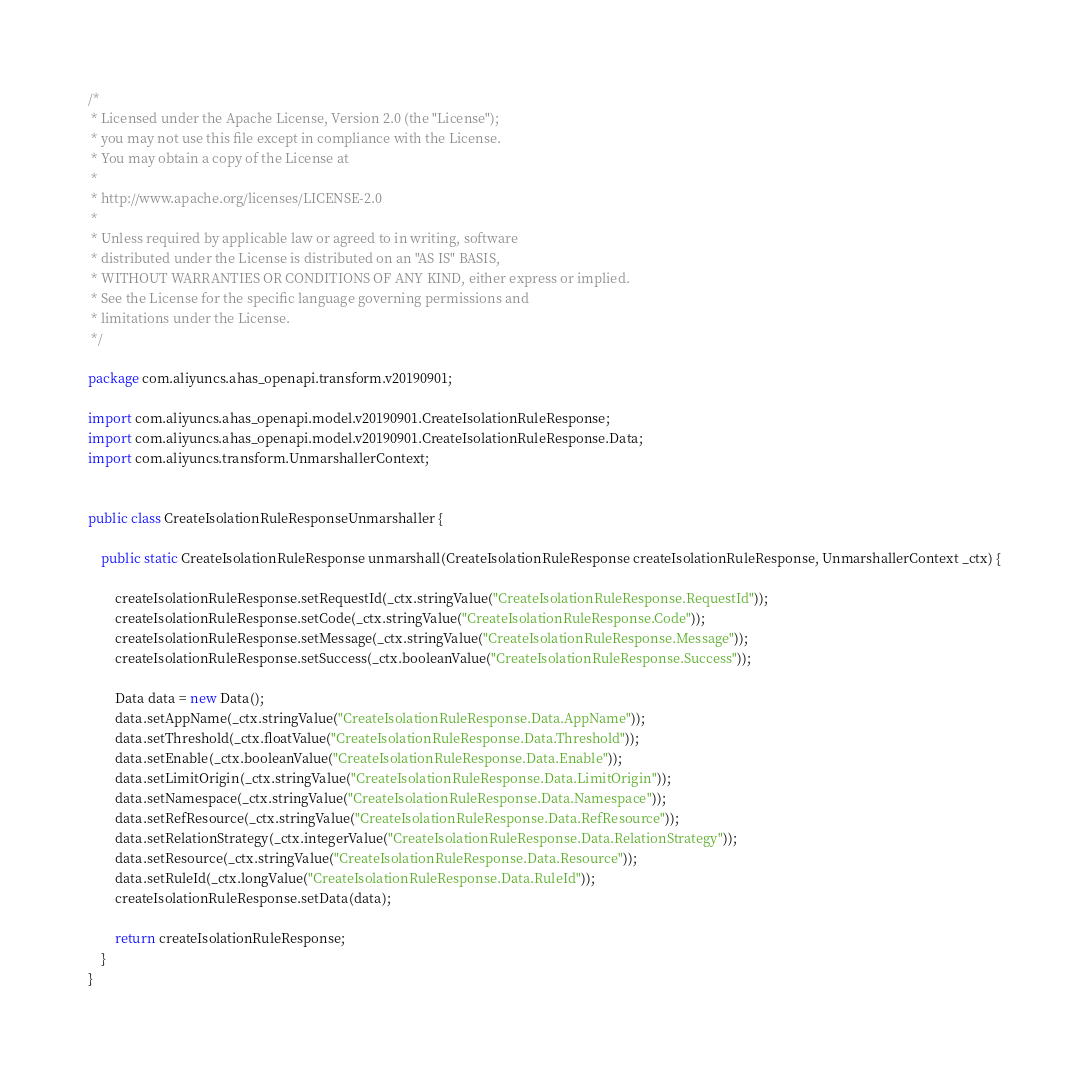Convert code to text. <code><loc_0><loc_0><loc_500><loc_500><_Java_>/*
 * Licensed under the Apache License, Version 2.0 (the "License");
 * you may not use this file except in compliance with the License.
 * You may obtain a copy of the License at
 *
 * http://www.apache.org/licenses/LICENSE-2.0
 *
 * Unless required by applicable law or agreed to in writing, software
 * distributed under the License is distributed on an "AS IS" BASIS,
 * WITHOUT WARRANTIES OR CONDITIONS OF ANY KIND, either express or implied.
 * See the License for the specific language governing permissions and
 * limitations under the License.
 */

package com.aliyuncs.ahas_openapi.transform.v20190901;

import com.aliyuncs.ahas_openapi.model.v20190901.CreateIsolationRuleResponse;
import com.aliyuncs.ahas_openapi.model.v20190901.CreateIsolationRuleResponse.Data;
import com.aliyuncs.transform.UnmarshallerContext;


public class CreateIsolationRuleResponseUnmarshaller {

	public static CreateIsolationRuleResponse unmarshall(CreateIsolationRuleResponse createIsolationRuleResponse, UnmarshallerContext _ctx) {
		
		createIsolationRuleResponse.setRequestId(_ctx.stringValue("CreateIsolationRuleResponse.RequestId"));
		createIsolationRuleResponse.setCode(_ctx.stringValue("CreateIsolationRuleResponse.Code"));
		createIsolationRuleResponse.setMessage(_ctx.stringValue("CreateIsolationRuleResponse.Message"));
		createIsolationRuleResponse.setSuccess(_ctx.booleanValue("CreateIsolationRuleResponse.Success"));

		Data data = new Data();
		data.setAppName(_ctx.stringValue("CreateIsolationRuleResponse.Data.AppName"));
		data.setThreshold(_ctx.floatValue("CreateIsolationRuleResponse.Data.Threshold"));
		data.setEnable(_ctx.booleanValue("CreateIsolationRuleResponse.Data.Enable"));
		data.setLimitOrigin(_ctx.stringValue("CreateIsolationRuleResponse.Data.LimitOrigin"));
		data.setNamespace(_ctx.stringValue("CreateIsolationRuleResponse.Data.Namespace"));
		data.setRefResource(_ctx.stringValue("CreateIsolationRuleResponse.Data.RefResource"));
		data.setRelationStrategy(_ctx.integerValue("CreateIsolationRuleResponse.Data.RelationStrategy"));
		data.setResource(_ctx.stringValue("CreateIsolationRuleResponse.Data.Resource"));
		data.setRuleId(_ctx.longValue("CreateIsolationRuleResponse.Data.RuleId"));
		createIsolationRuleResponse.setData(data);
	 
	 	return createIsolationRuleResponse;
	}
}</code> 